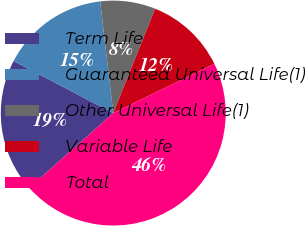Convert chart to OTSL. <chart><loc_0><loc_0><loc_500><loc_500><pie_chart><fcel>Term Life<fcel>Guaranteed Universal Life(1)<fcel>Other Universal Life(1)<fcel>Variable Life<fcel>Total<nl><fcel>19.25%<fcel>15.48%<fcel>7.94%<fcel>11.71%<fcel>45.63%<nl></chart> 